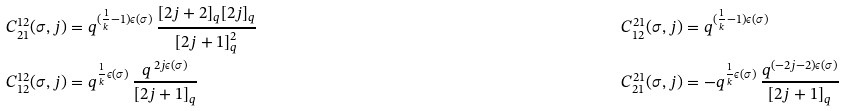<formula> <loc_0><loc_0><loc_500><loc_500>C _ { 2 1 } ^ { 1 2 } ( \sigma , j ) & = q ^ { ( \frac { 1 } { k } - 1 ) \epsilon ( \sigma ) } \, \frac { [ 2 j + 2 ] _ { q } [ 2 j ] _ { q } } { [ 2 j + 1 ] _ { q } ^ { 2 } } & C _ { 1 2 } ^ { 2 1 } ( \sigma , j ) & = q ^ { ( \frac { 1 } { k } - 1 ) \epsilon ( \sigma ) } \\ C _ { 1 2 } ^ { 1 2 } ( \sigma , j ) & = q ^ { \frac { 1 } { k } \epsilon ( \sigma ) } \, \frac { q ^ { \, 2 j \epsilon ( \sigma ) } } { [ 2 j + 1 ] _ { q } } & C _ { 2 1 } ^ { 2 1 } ( \sigma , j ) & = - q ^ { \frac { 1 } { k } \epsilon ( \sigma ) } \, \frac { q ^ { ( - 2 j - 2 ) \epsilon ( \sigma ) } } { [ 2 j + 1 ] _ { q } }</formula> 